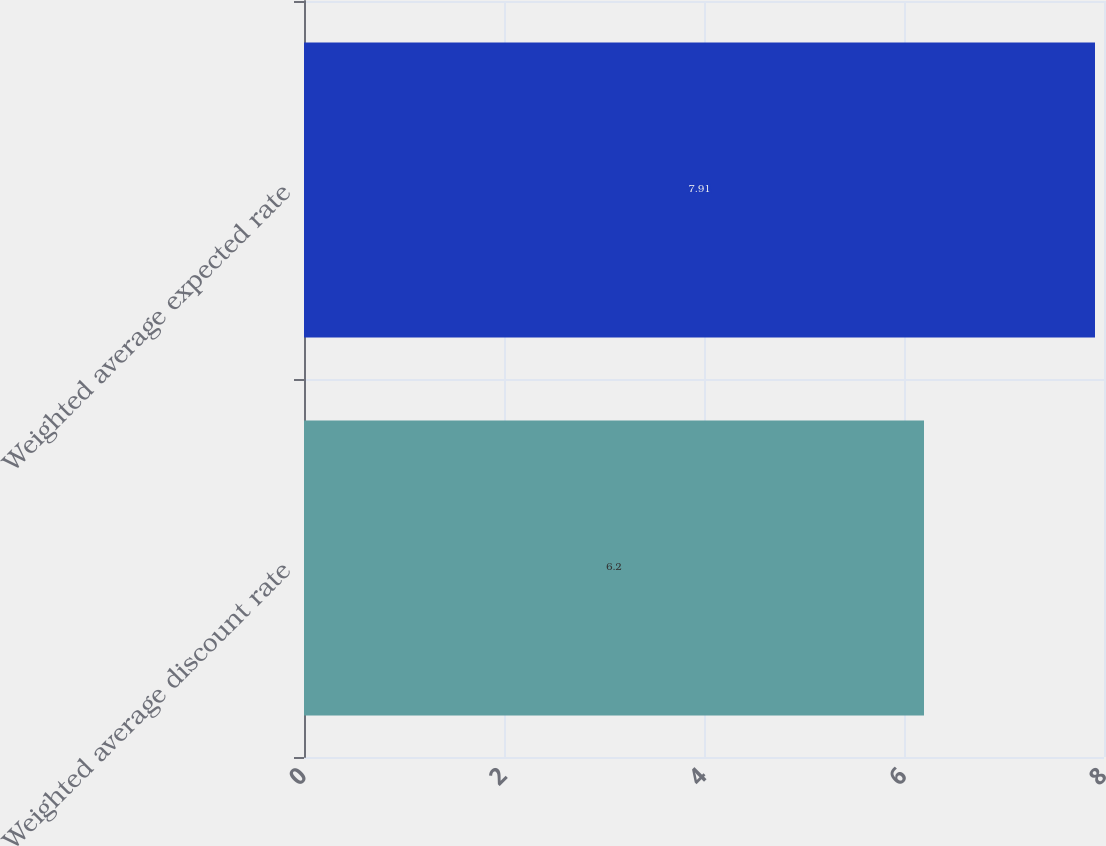Convert chart. <chart><loc_0><loc_0><loc_500><loc_500><bar_chart><fcel>Weighted average discount rate<fcel>Weighted average expected rate<nl><fcel>6.2<fcel>7.91<nl></chart> 